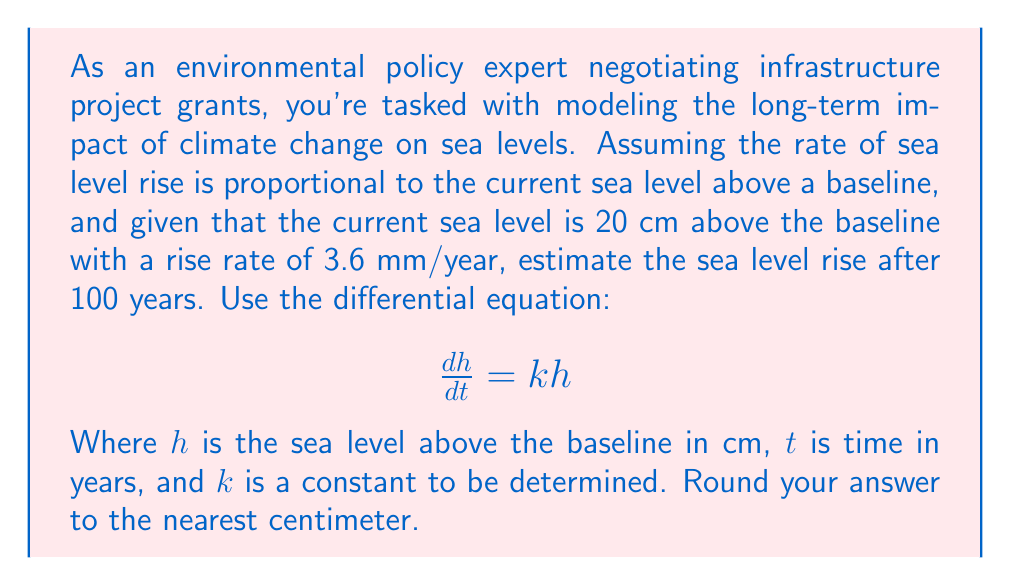Help me with this question. To solve this problem, we'll follow these steps:

1) First, we need to determine the constant $k$ using the given initial conditions:
   $h(0) = 20$ cm and $\frac{dh}{dt}(0) = 0.36$ cm/year

2) Substituting these into the differential equation:
   $0.36 = k(20)$
   $k = 0.018$ year$^{-1}$

3) The general solution to the differential equation $\frac{dh}{dt} = kh$ is:
   $h(t) = Ce^{kt}$

4) Using the initial condition $h(0) = 20$:
   $20 = Ce^{k(0)}$
   $C = 20$

5) Therefore, our specific solution is:
   $h(t) = 20e^{0.018t}$

6) To find the sea level after 100 years, we evaluate $h(100)$:
   $h(100) = 20e^{0.018(100)}$
   $h(100) = 20e^{1.8}$
   $h(100) \approx 120.96$ cm

7) The sea level rise is the difference between this and the initial level:
   $120.96 - 20 \approx 100.96$ cm

8) Rounding to the nearest centimeter:
   $100.96 \approx 101$ cm
Answer: The estimated sea level rise after 100 years is 101 cm. 